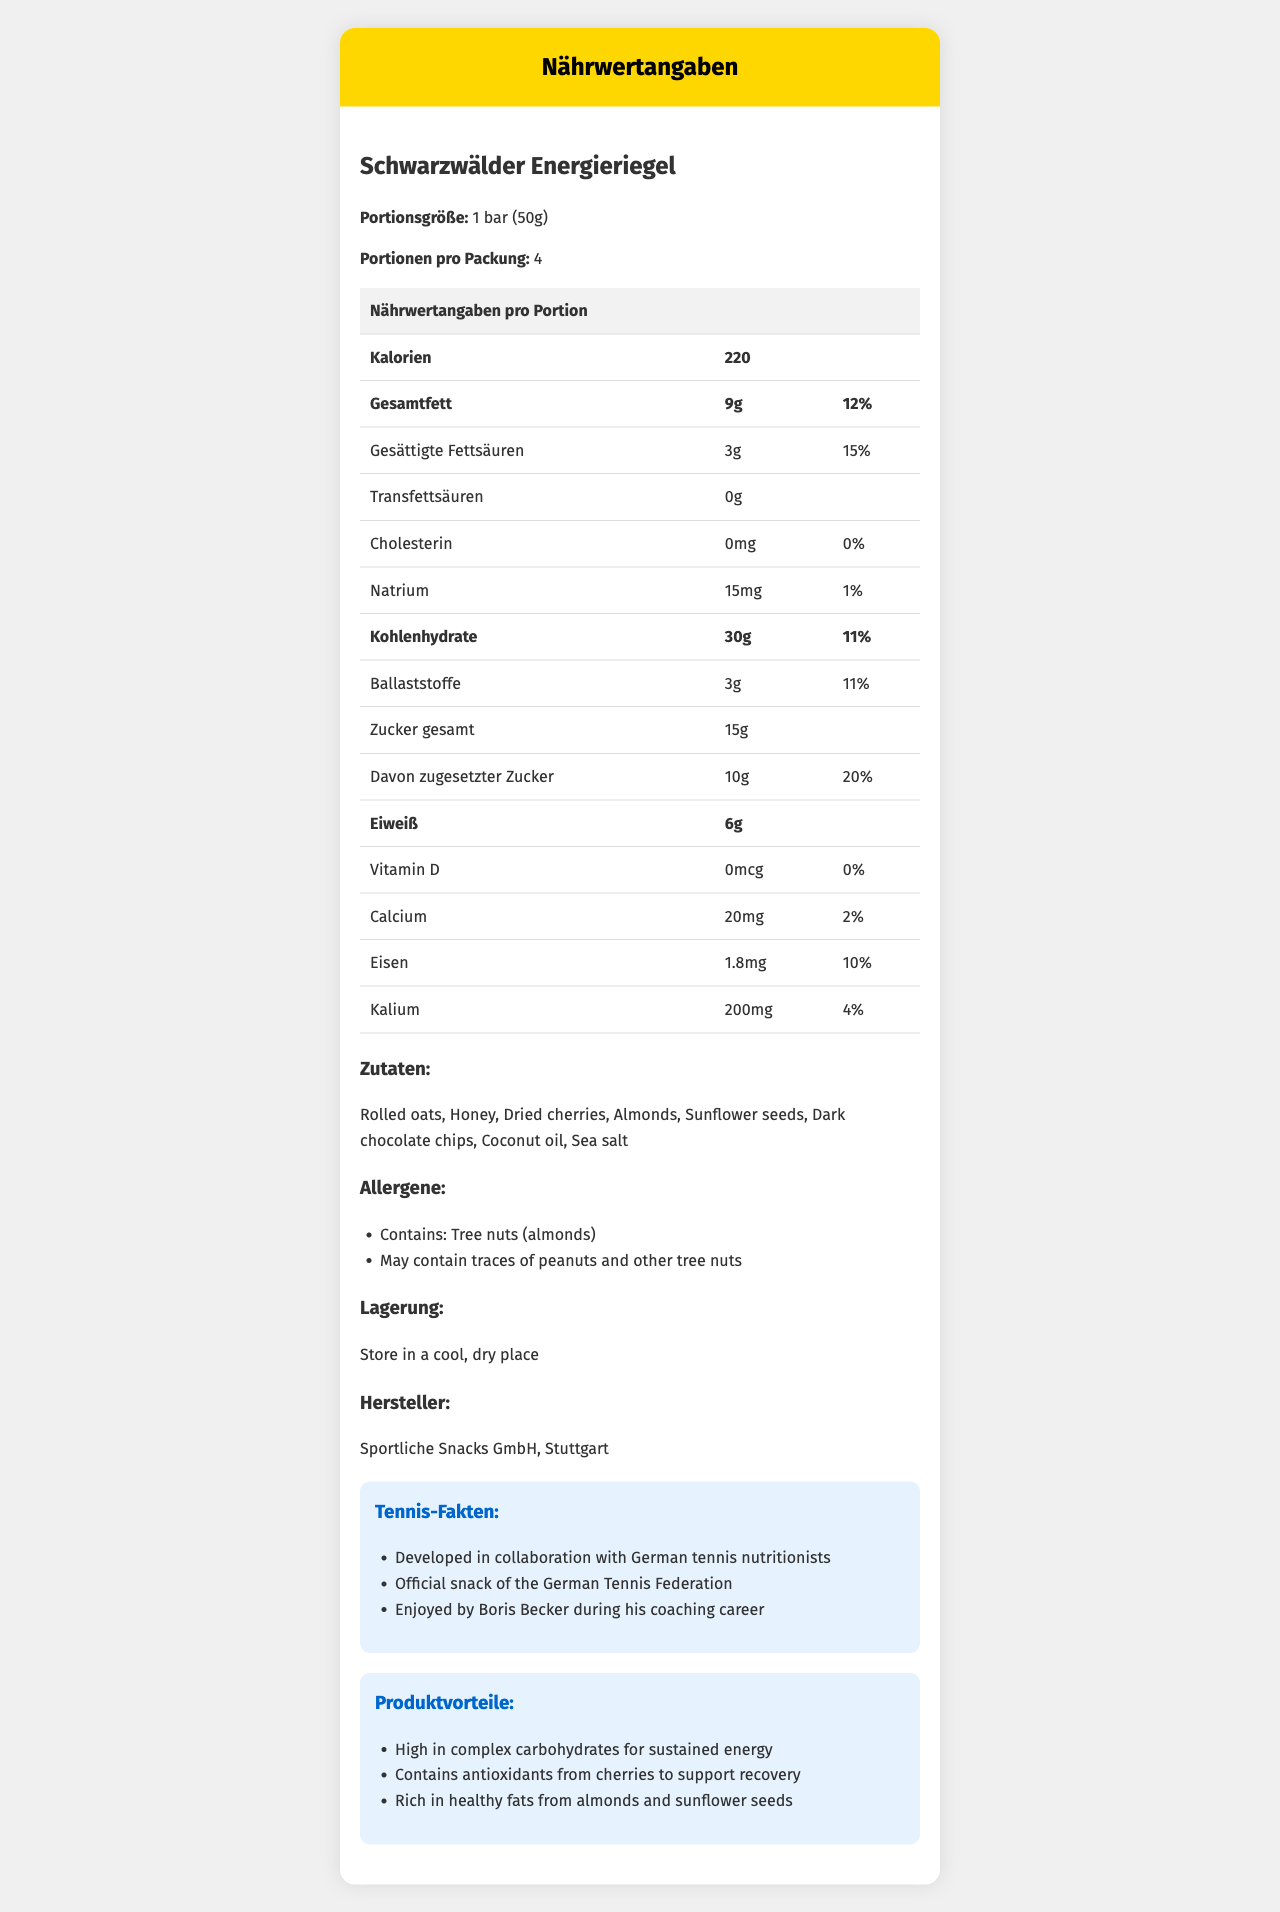What is the serving size of the Schwarzwälder Energieriegel? The document specifies the serving size as "1 bar (50g)".
Answer: 1 bar (50g) How many servings are there per container? The document mentions that there are 4 servings per container.
Answer: 4 What is the total fat content per serving? The total fat content per serving is listed as "9g".
Answer: 9g How much protein does one bar contain? The amount of protein per serving is shown as "6g".
Answer: 6g What is the total carbohydrate content in each serving of the energy bar? The document lists the total carbohydrate content as "30g".
Answer: 30g How much added sugar does the Schwarzwälder Energieriegel contain? The document shows that the energy bar contains "10g" of added sugars.
Answer: 10g Which allergen is explicitly mentioned as being contained in the product? A. Peanuts B. Almonds C. Hazelnuts D. Walnuts The document mentions that the product "Contains: Tree nuts (almonds)".
Answer: B. Almonds What percentage of the daily value is the saturated fat content? A. 10% B. 12% C. 15% D. 20% The saturated fat content is listed as "3g" with a daily value percentage of "15%".
Answer: C. 15% Are there any trans fats in the Schwarzwälder Energieriegel? The document indicates "0g" trans fats under the nutritional information.
Answer: No What is the official snack of the German Tennis Federation? One of the tennis facts listed is that it is the "Official snack of the German Tennis Federation".
Answer: Schwarzwälder Energieriegel Describe the key features and benefits of Schwarzwälder Energieriegel. This summary covers the nutritional data, ingredients, benefits, and tennis-related endorsements mentioned in the document.
Answer: The Schwarzwälder Energieriegel is a traditional German energy snack with a serving size of 1 bar (50g) and 220 calories per serving. It contains 9g of total fat, 6g of protein, and 30g of total carbohydrates per serving. It includes ingredients like rolled oats, honey, dried cherries, almonds, and dark chocolate chips. The product is notable for being high in complex carbohydrates for sustained energy, containing antioxidants from cherries to support recovery, and being rich in healthy fats from almonds and sunflower seeds. It is officially recognized by the German Tennis Federation and was enjoyed by Boris Becker. How does the Schwarzwälder Energieriegel help in supporting recovery? The document mentions that the energy bar "contains antioxidants from cherries to support recovery".
Answer: It contains antioxidants from cherries. What is the name of the manufacturer of Schwarzwälder Energieriegel? The manufacturer is listed as "Sportliche Snacks GmbH, Stuttgart" in the document.
Answer: Sportliche Snacks GmbH, Stuttgart Who enjoyed the Schwarzwälder Energieriegel during his coaching career? The document states that Boris Becker enjoyed the product during his coaching career.
Answer: Boris Becker How much potassium is in each serving of the Schwarzwälder Energieriegel? The potassium content per serving is listed as "200mg".
Answer: 200mg Can the document determine if the Schwarzwälder Energieriegel is suitable for vegans? The document lists the ingredients, but it does not state whether the product is suitable for vegans or discuss the presence of animal-derived ingredients specifically.
Answer: Not enough information 